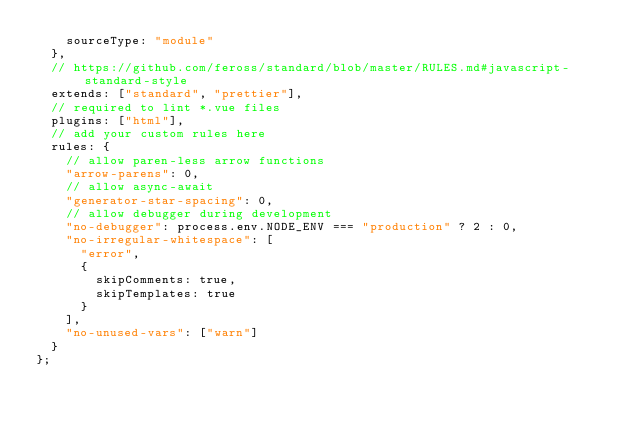Convert code to text. <code><loc_0><loc_0><loc_500><loc_500><_JavaScript_>    sourceType: "module"
  },
  // https://github.com/feross/standard/blob/master/RULES.md#javascript-standard-style
  extends: ["standard", "prettier"],
  // required to lint *.vue files
  plugins: ["html"],
  // add your custom rules here
  rules: {
    // allow paren-less arrow functions
    "arrow-parens": 0,
    // allow async-await
    "generator-star-spacing": 0,
    // allow debugger during development
    "no-debugger": process.env.NODE_ENV === "production" ? 2 : 0,
    "no-irregular-whitespace": [
      "error",
      {
        skipComments: true,
        skipTemplates: true
      }
    ],
    "no-unused-vars": ["warn"]
  }
};
</code> 